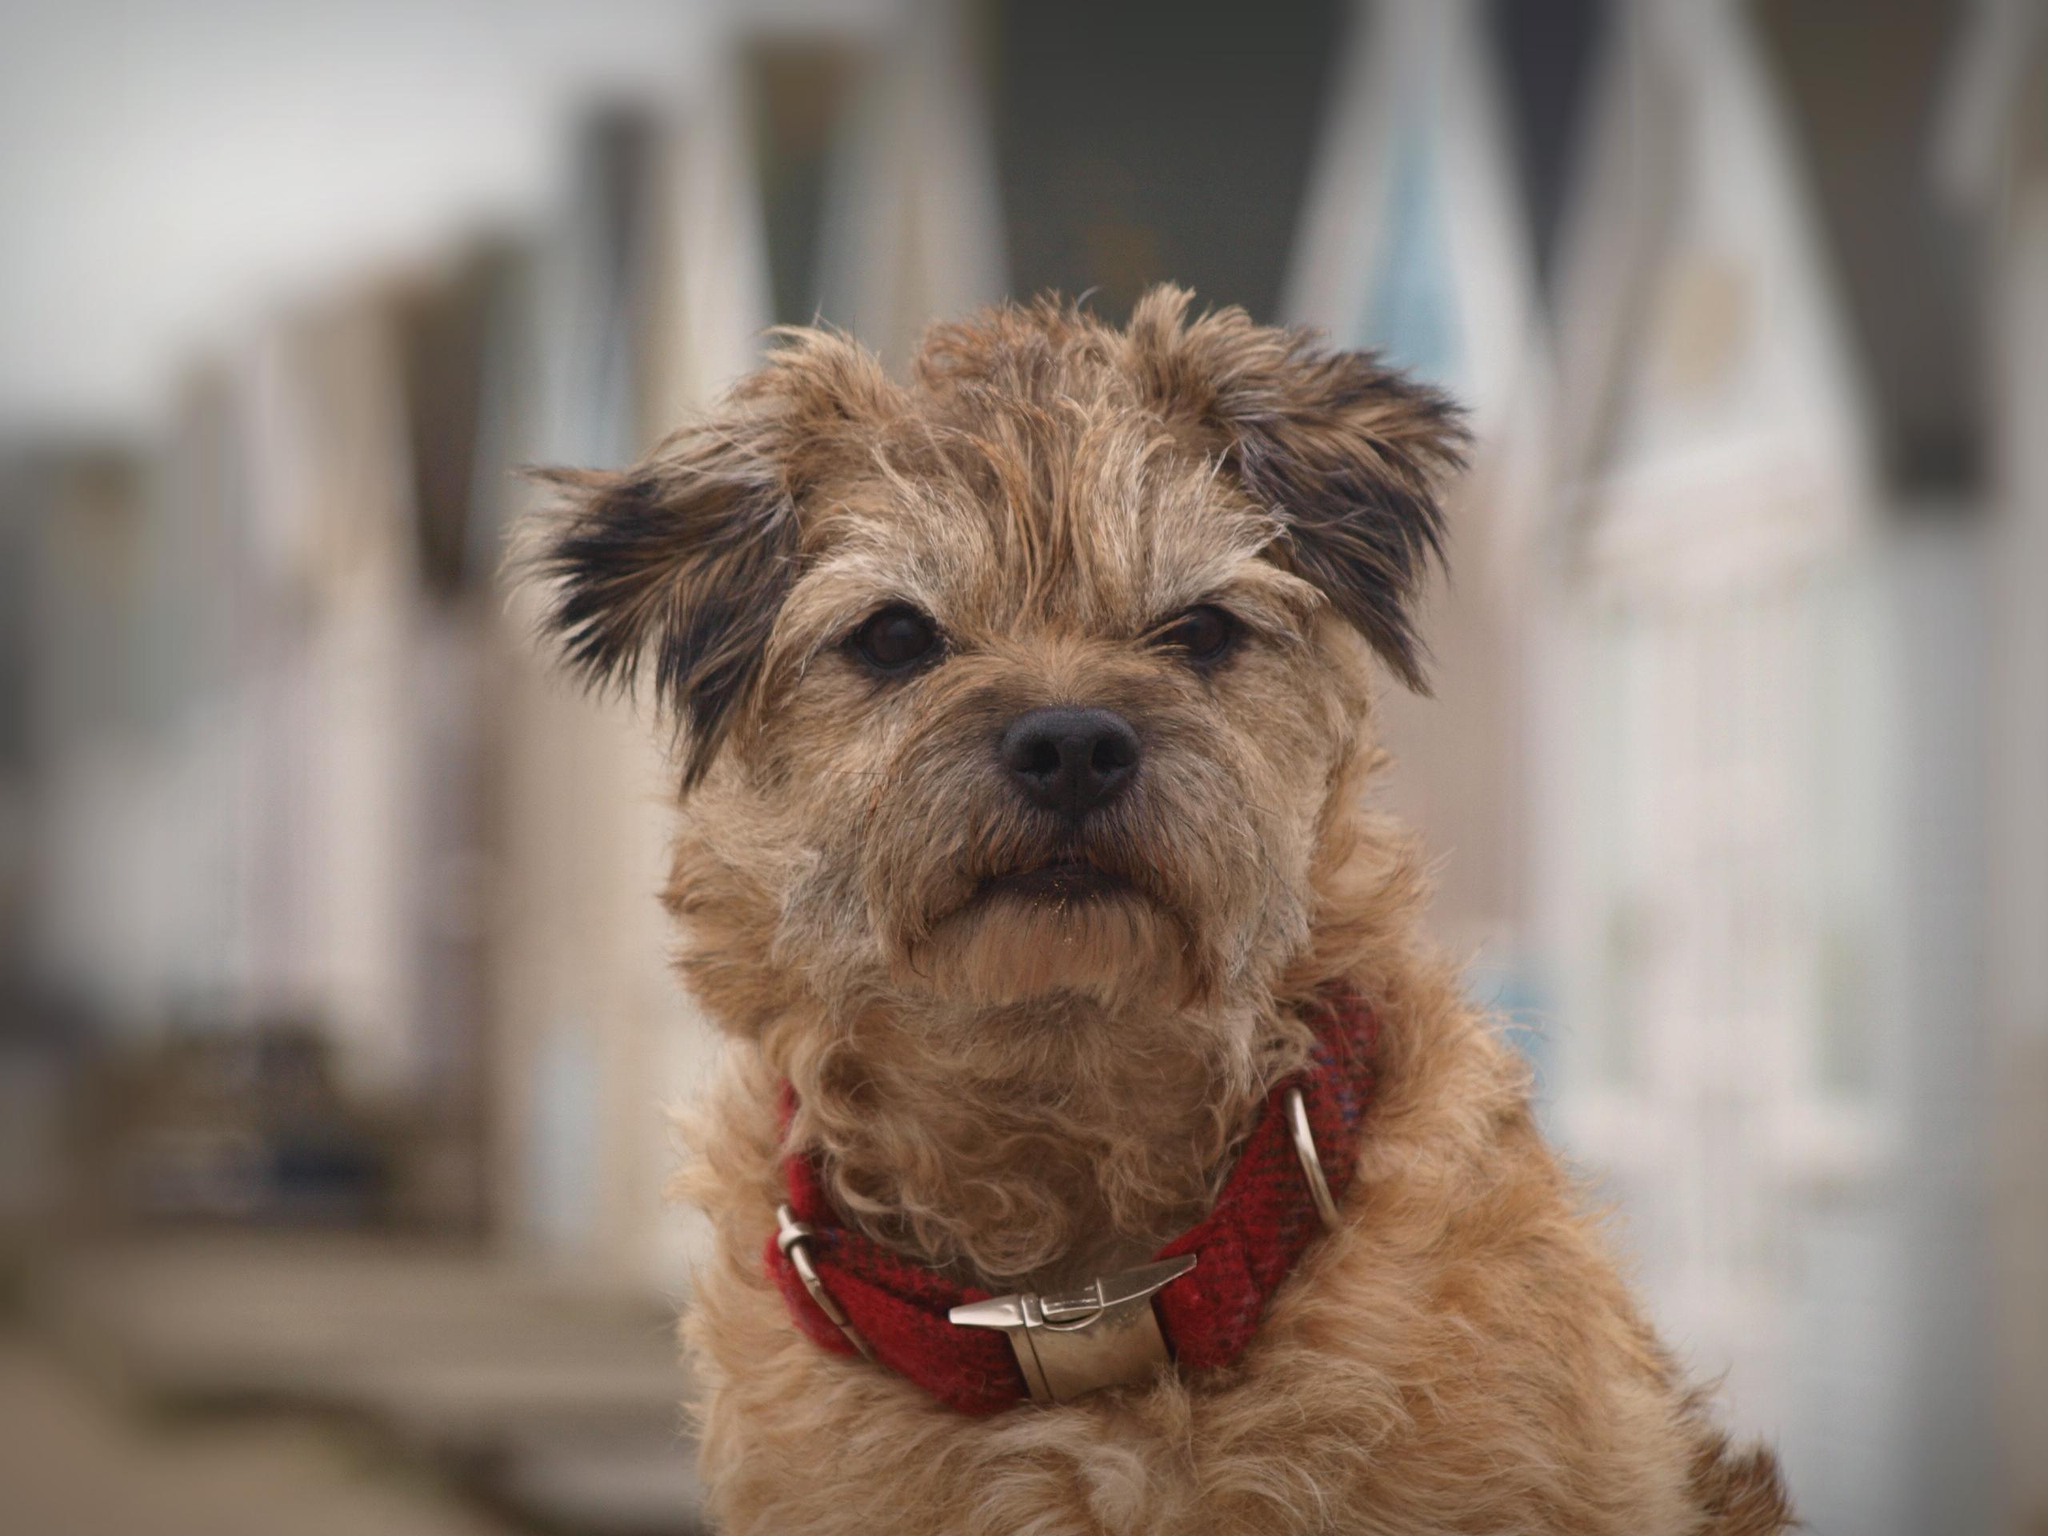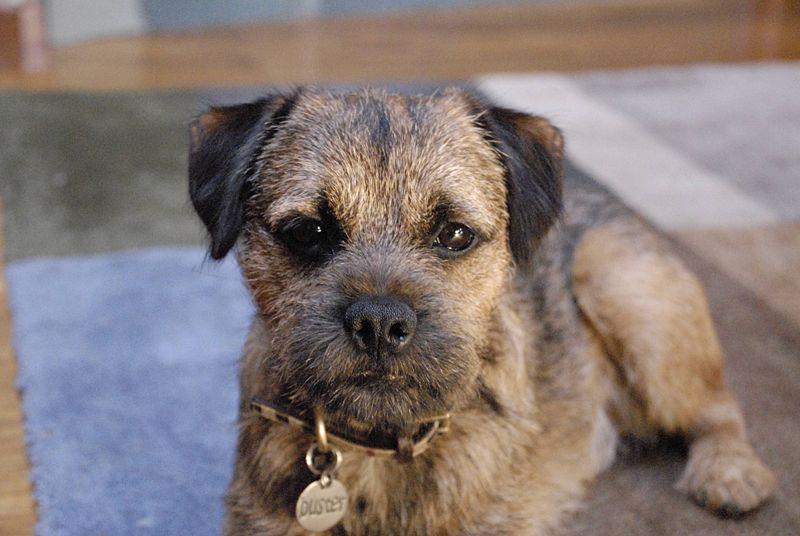The first image is the image on the left, the second image is the image on the right. Evaluate the accuracy of this statement regarding the images: "There are two dogs wearing a collar.". Is it true? Answer yes or no. Yes. 